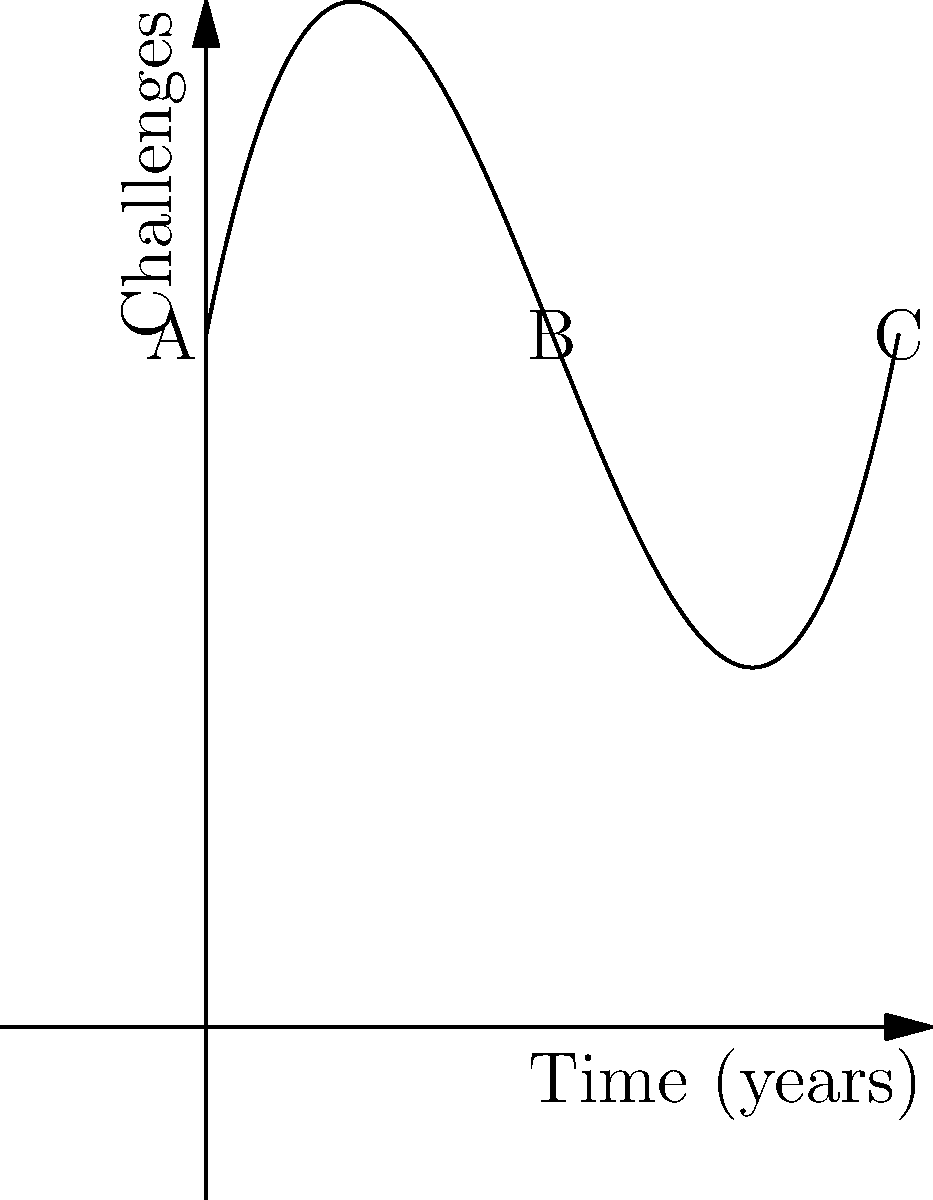The graph shows a polynomial function representing the challenges faced by immigrants over time. Point A represents the initial challenges, point B represents a period of relative stability, and point C shows increasing difficulties. If the function is of the form $f(x) = ax^3 + bx^2 + cx + d$, what is the sign of the coefficient $a$, and how does it relate to the long-term trajectory of immigrant challenges? To determine the sign of coefficient $a$ and its relation to the long-term trajectory of immigrant challenges, we need to analyze the graph:

1. Observe the overall shape of the curve: It starts high, decreases to a minimum, then increases again.

2. Focus on the end behavior: As x increases (moving towards point C), the curve is rising at an increasing rate.

3. For a cubic function $f(x) = ax^3 + bx^2 + cx + d$:
   - If $a > 0$, the function will eventually rise as x increases.
   - If $a < 0$, the function will eventually fall as x increases.

4. In this graph, we see the function rising as x increases towards point C, indicating that $a > 0$.

5. The positive $a$ coefficient means that in the long term, the challenges faced by immigrants are increasing at an accelerating rate.

6. This aligns with the narrative of initially high challenges (A), a period of improvement and stability (B), followed by renewed and intensifying difficulties (C).
Answer: $a > 0$; indicates accelerating long-term challenges 